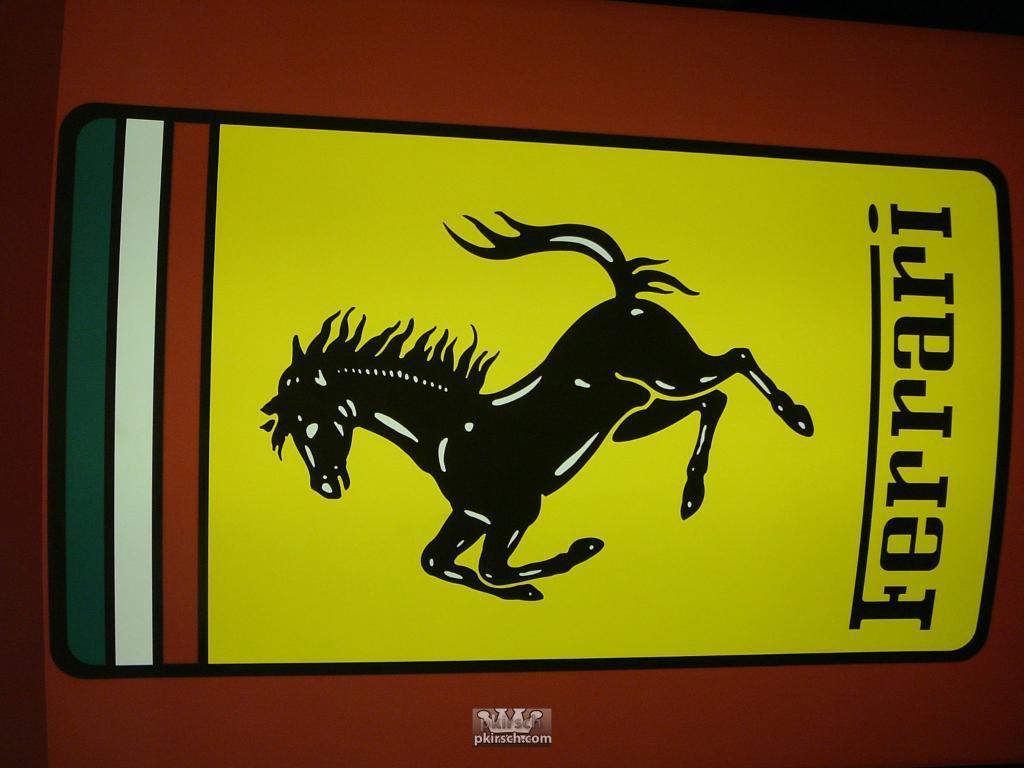Please provide a concise description of this image. In the image in the center we can see one object. On the object,we can see we one horse image and some text. 